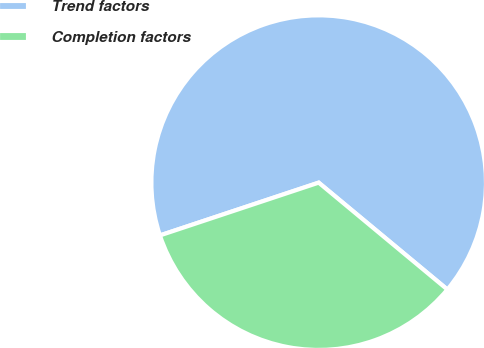<chart> <loc_0><loc_0><loc_500><loc_500><pie_chart><fcel>Trend factors<fcel>Completion factors<nl><fcel>66.14%<fcel>33.86%<nl></chart> 